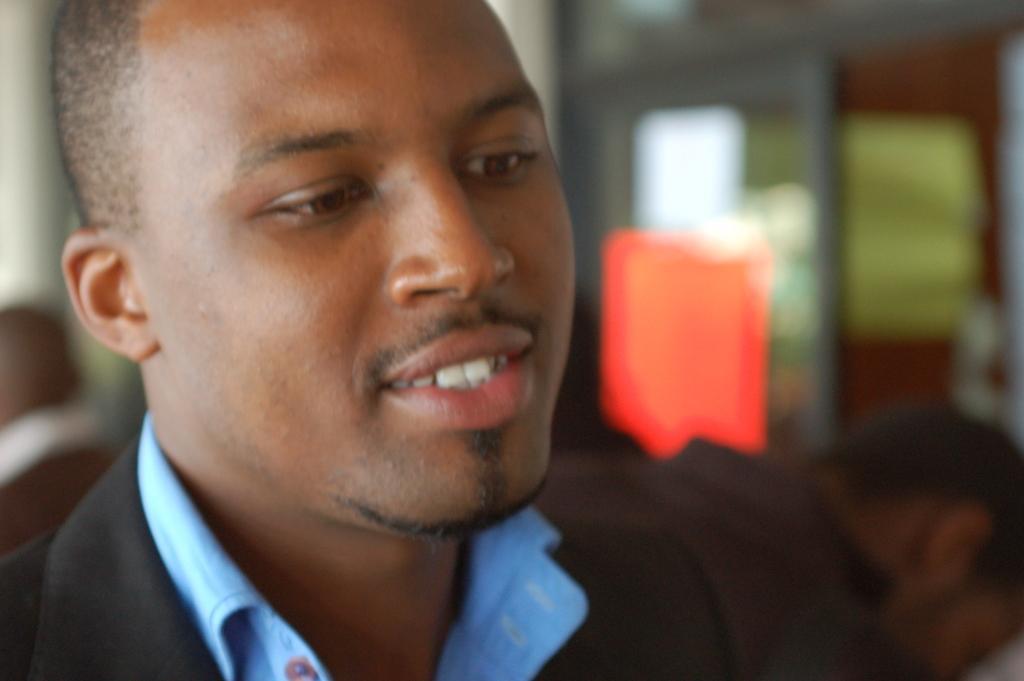Can you describe this image briefly? In the front of the image we can see a person. In the background of the image it is blurry and we can see people. 